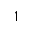<formula> <loc_0><loc_0><loc_500><loc_500>1</formula> 